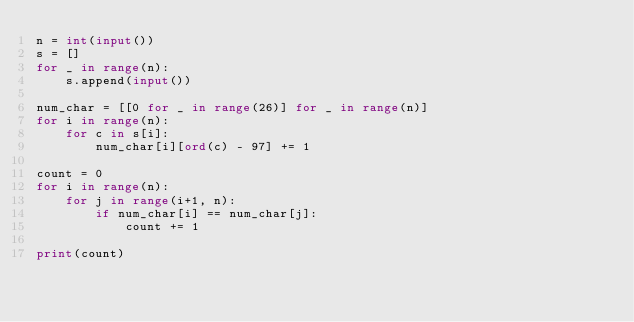<code> <loc_0><loc_0><loc_500><loc_500><_Python_>n = int(input())
s = []
for _ in range(n):
    s.append(input())

num_char = [[0 for _ in range(26)] for _ in range(n)]
for i in range(n):
    for c in s[i]:
        num_char[i][ord(c) - 97] += 1

count = 0
for i in range(n):
    for j in range(i+1, n):
        if num_char[i] == num_char[j]:
            count += 1

print(count)
</code> 